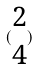Convert formula to latex. <formula><loc_0><loc_0><loc_500><loc_500>( \begin{matrix} 2 \\ 4 \end{matrix} )</formula> 